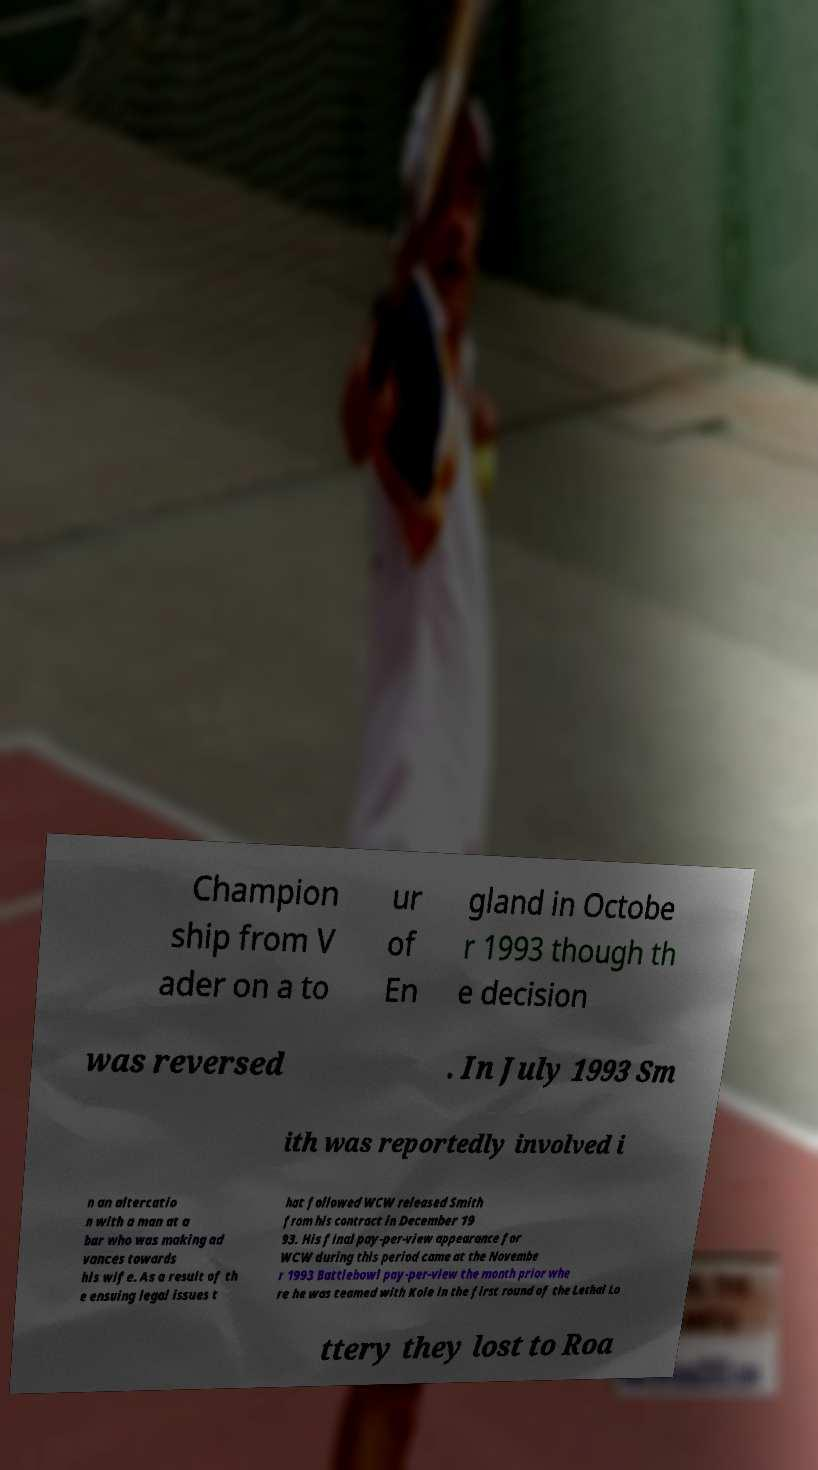Can you accurately transcribe the text from the provided image for me? Champion ship from V ader on a to ur of En gland in Octobe r 1993 though th e decision was reversed . In July 1993 Sm ith was reportedly involved i n an altercatio n with a man at a bar who was making ad vances towards his wife. As a result of th e ensuing legal issues t hat followed WCW released Smith from his contract in December 19 93. His final pay-per-view appearance for WCW during this period came at the Novembe r 1993 Battlebowl pay-per-view the month prior whe re he was teamed with Kole in the first round of the Lethal Lo ttery they lost to Roa 